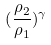Convert formula to latex. <formula><loc_0><loc_0><loc_500><loc_500>( \frac { \rho _ { 2 } } { \rho _ { 1 } } ) ^ { \gamma }</formula> 